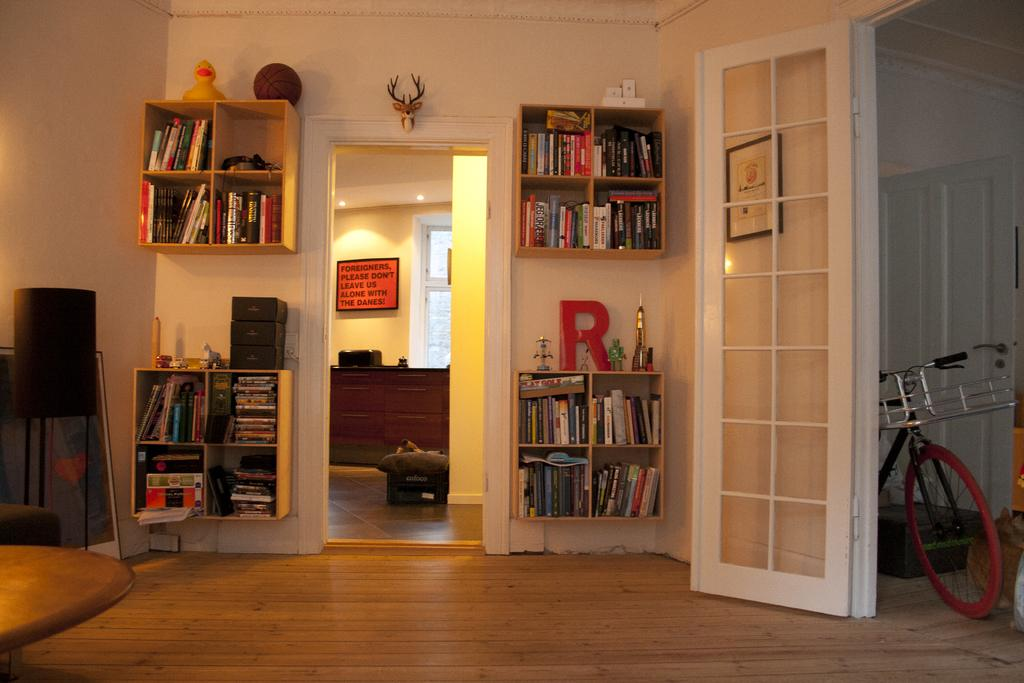<image>
Share a concise interpretation of the image provided. A large red R sits on a shelf to the right with some other trinkets. 